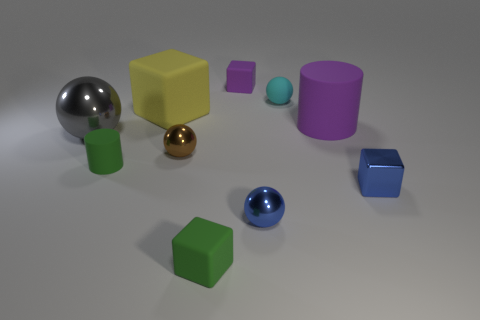Do the small purple thing and the green matte thing that is to the right of the big yellow matte thing have the same shape?
Offer a terse response. Yes. There is a block that is left of the small cyan sphere and in front of the large purple cylinder; what is its color?
Provide a succinct answer. Green. What is the material of the tiny sphere left of the matte cube that is in front of the tiny blue object that is right of the purple matte cylinder?
Your answer should be very brief. Metal. What is the material of the blue sphere?
Ensure brevity in your answer.  Metal. There is a green matte thing that is the same shape as the yellow rubber object; what size is it?
Keep it short and to the point. Small. How many other objects are there of the same material as the brown object?
Offer a very short reply. 3. Is the number of tiny cyan rubber objects on the left side of the tiny green cube the same as the number of large gray shiny blocks?
Make the answer very short. Yes. There is a matte sphere that is behind the brown metal object; is its size the same as the tiny purple cube?
Give a very brief answer. Yes. There is a large yellow block; what number of small blocks are behind it?
Your answer should be compact. 1. The thing that is both to the right of the cyan rubber thing and in front of the big shiny ball is made of what material?
Provide a short and direct response. Metal. 